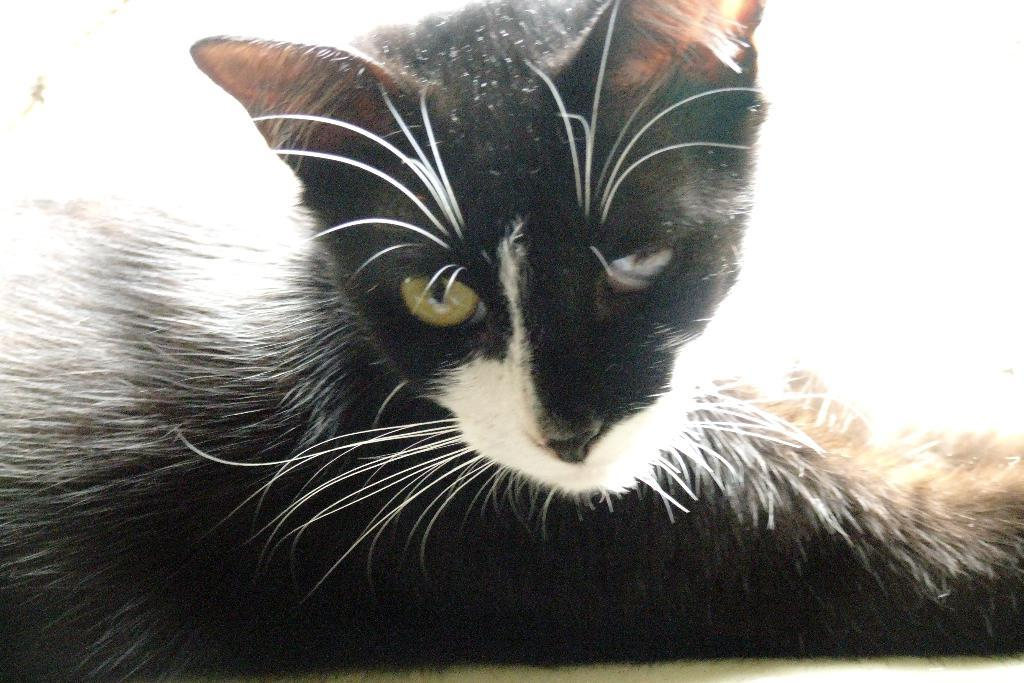What type of animal is in the image? There is a black color cat in the image. Where is the cat located in the image? The cat is on a path. What grade does the cat receive for its performance in the image? There is no grading system or performance evaluation for the cat in the image, as it is a photograph and not an event or activity. 